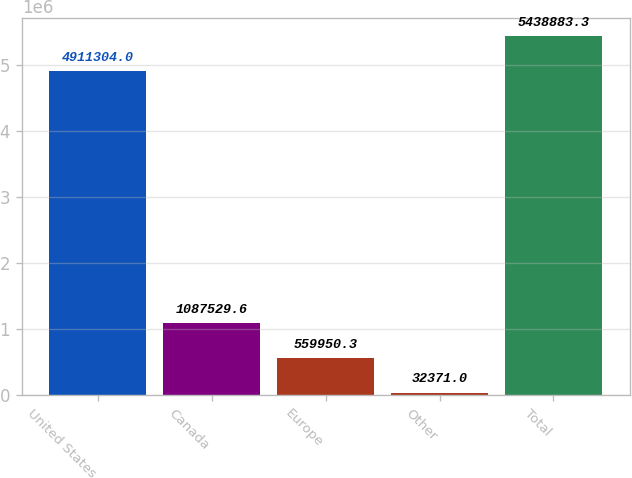Convert chart to OTSL. <chart><loc_0><loc_0><loc_500><loc_500><bar_chart><fcel>United States<fcel>Canada<fcel>Europe<fcel>Other<fcel>Total<nl><fcel>4.9113e+06<fcel>1.08753e+06<fcel>559950<fcel>32371<fcel>5.43888e+06<nl></chart> 